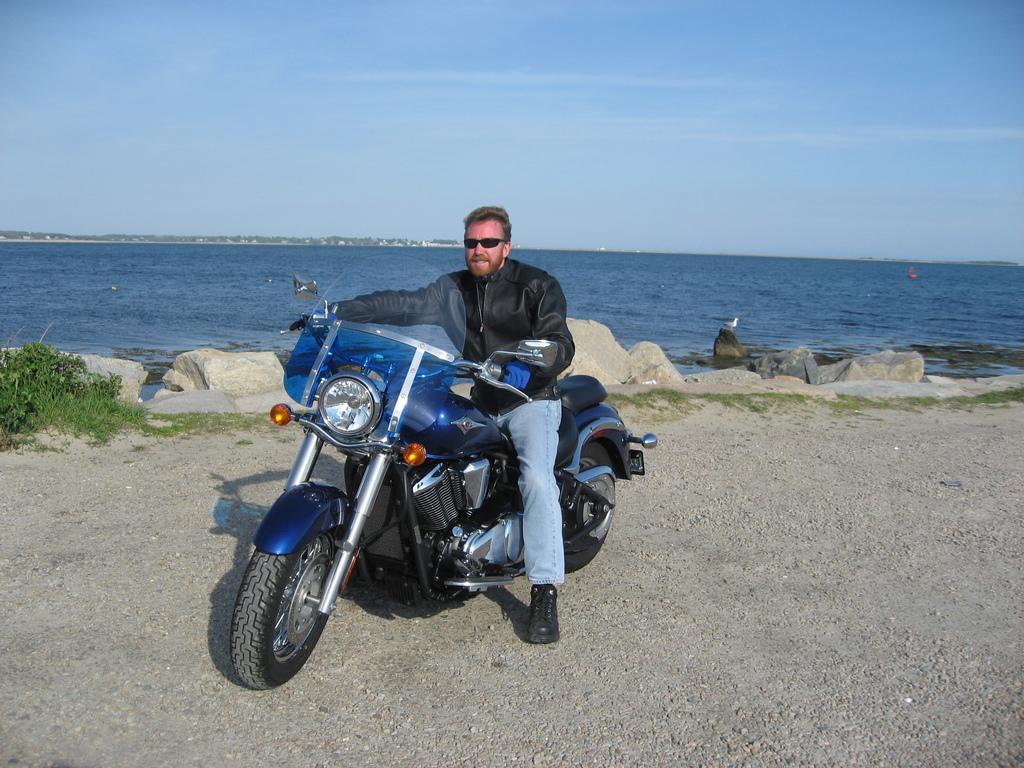How would you summarize this image in a sentence or two? A person is sitting on a motorbike. Background we can see water, plants, rocks and sky. 